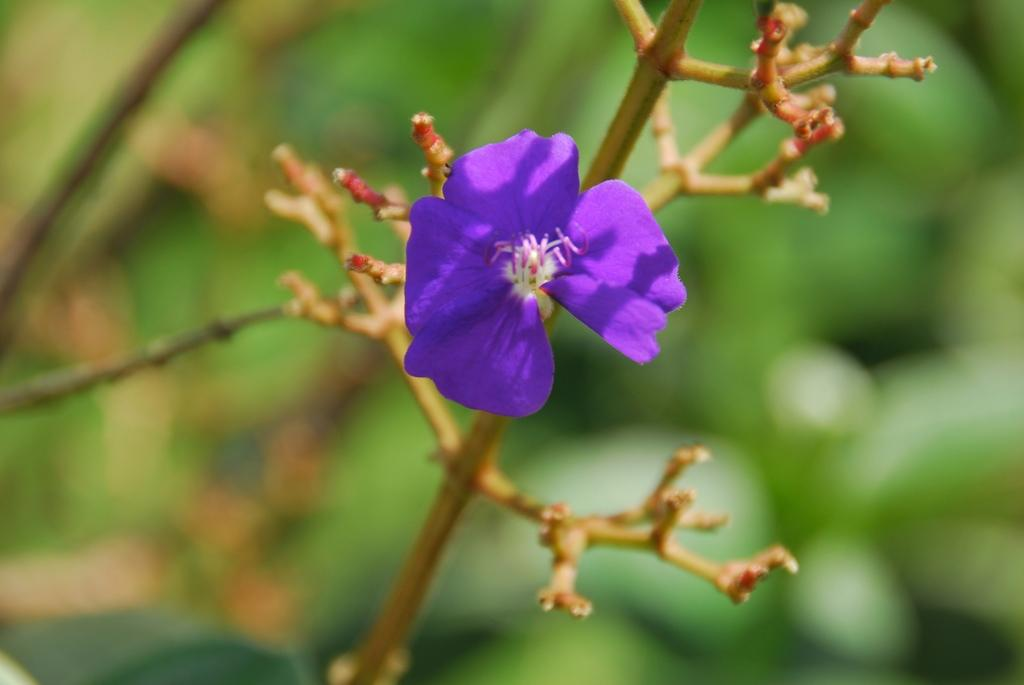What is the main object in the image? There is a branch in the image. What is attached to the branch? The branch contains a flower. What color is the flower? The flower is violet in color. How would you describe the background of the image? The background of the image is blurred. How many blades are visible in the image? There are no blades present in the image; it features a branch with a violet flower. What type of coin can be seen near the flower in the image? There is no coin present in the image; it only contains a branch with a violet flower and a blurred background. 